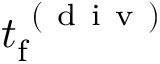<formula> <loc_0><loc_0><loc_500><loc_500>t _ { f } ^ { ( d i v ) }</formula> 